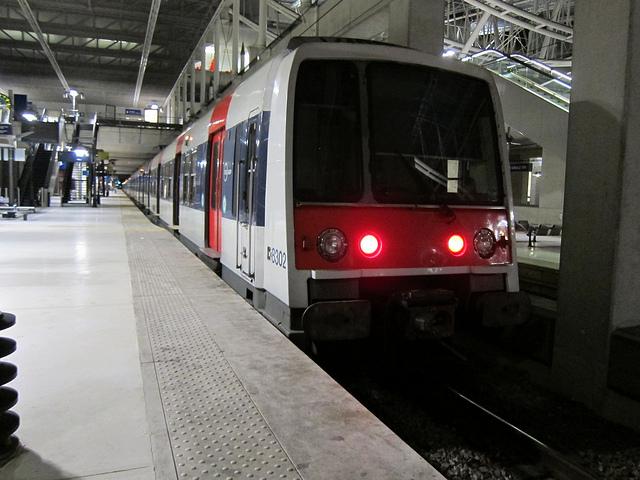What color is the end of the train?
Be succinct. Red. Is the front of the train designed with aerodynamics?
Answer briefly. No. Is this train station full of people?
Be succinct. No. Can anyone be seen on the train?
Quick response, please. No. How can you tell this train is meant to go fast?
Answer briefly. Shape. What kind of train is this?
Keep it brief. Passenger. How many red lights are there?
Concise answer only. 2. How many lights are lit on the front of the train?
Give a very brief answer. 2. 